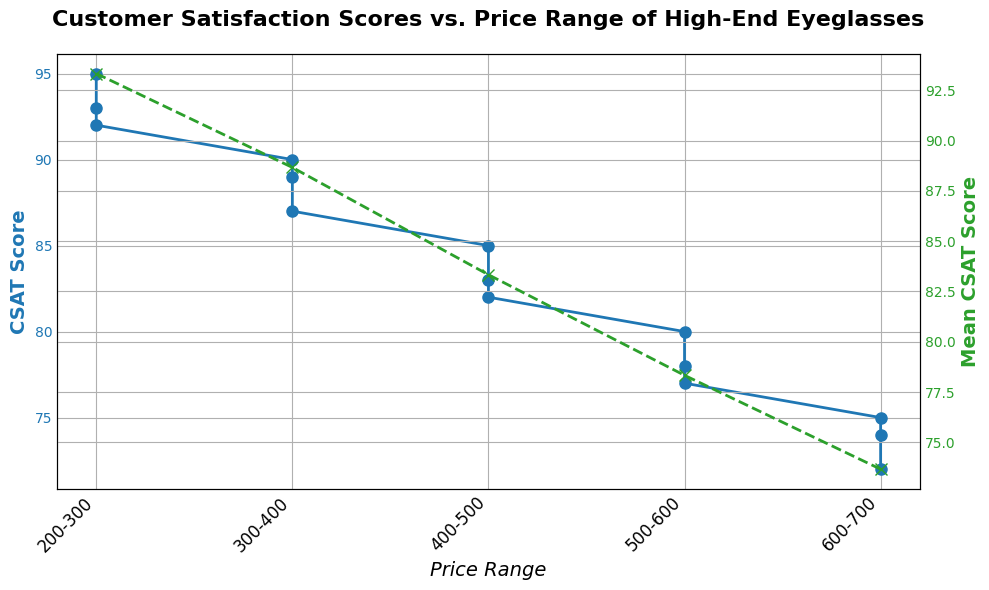What is the average CSAT Score for the price range 400-500? To find the average CSAT Score for the price range 400-500, look at the blue curve values at the x-axis marking for this price range. The scores are 85, 83, and 82. Calculate the average: (85 + 83 + 82) / 3 = 83.33
Answer: 83.33 Which price range has the highest Mean CSAT Score? To determine the highest Mean CSAT Score, look at the green curve on the secondary y-axis and compare their peaks. The peak occurs at the '200-300' price range.
Answer: 200-300 What is the difference in Mean CSAT Score between the price ranges 200-300 and 600-700? Identify the Mean CSAT Scores from the green curve at '200-300' and '600-700' price ranges, which are 93.33 and 73.67, respectively (calculated from the plot data). The difference is 93.33 - 73.67 = 19.66
Answer: 19.66 At which price range does the CSAT Score first drop below 85? Look at the blue curve's points and determine when it first goes below 85. The scores are recorded lower than 85 starting from the '400-500' price range.
Answer: 400-500 How does the Mean CSAT Score change from price range 200-300 to 300-400? Compare the Mean CSAT Scores from '200-300' and '300-400' on the green curve on the secondary y-axis. The scores are 93.33 and 88.67, respectively. It decreases by 93.33 - 88.67 = 4.66
Answer: It decreases by 4.66 At what price range is there the steepest decline in CSAT Score? To find the steepest decline, observe the sharpest descent in the blue curve. From '300-400' to '400-500', the CSAT Scores drop from 90 to 85, marking the steepest decline of 5 points within a single price range shift.
Answer: 300-400 to 400-500 Compare the Mean CSAT Score of the highest price range to that of the lowest price range. Which one is higher and by how much? Identify the Mean CSAT Scores from the green curve for the lowest and highest price ranges, '200-300' and '600-700', which are 93.33 and 73.67 respectively. The difference is 93.33 - 73.67 = 19.66; the '200-300' range is higher.
Answer: 200-300 is higher by 19.66 What visual element indicates the Mean CSAT Score on the chart? Look at the graphical markers in the plot. The green line with 'x' markers represents the Mean CSAT Score for each price range, as shown in the secondary y-axis.
Answer: Green line with 'x' markers Why might there be a secondary axis in the plot? The secondary y-axis helps to differentiate between individual CSAT Scores (blue line) and Mean CSAT Scores (green line), providing a clearer presentation of data trends over the same x-axis price ranges. It prevents overlapping and confusion.
Answer: To differentiate individual and mean CSAT Scores What can you infer about customer satisfaction trends as the price of eyeglasses increases? Analyzing both the blue and green curves, customer satisfaction (CSAT) tends to decrease as the price increases. This is reflected by both individual and Mean CSAT Scores dropping from the lower to higher price ranges.
Answer: Customer satisfaction decreases 